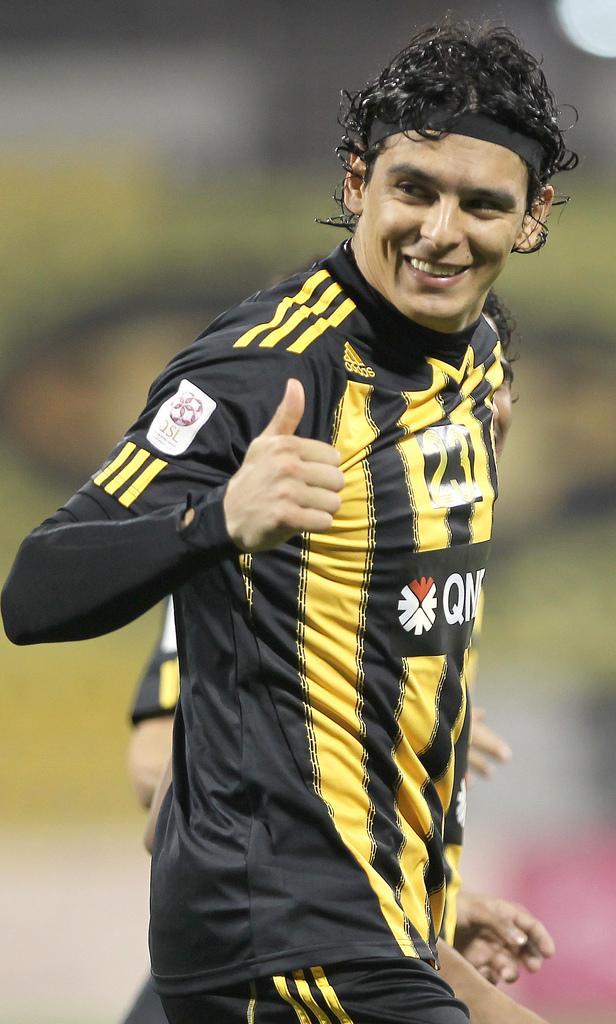Describe this image in one or two sentences. In this picture we can see a man in the black jersey and the man is smiling. Behind the man there is another person. Behind the two people there is the blurred background. 